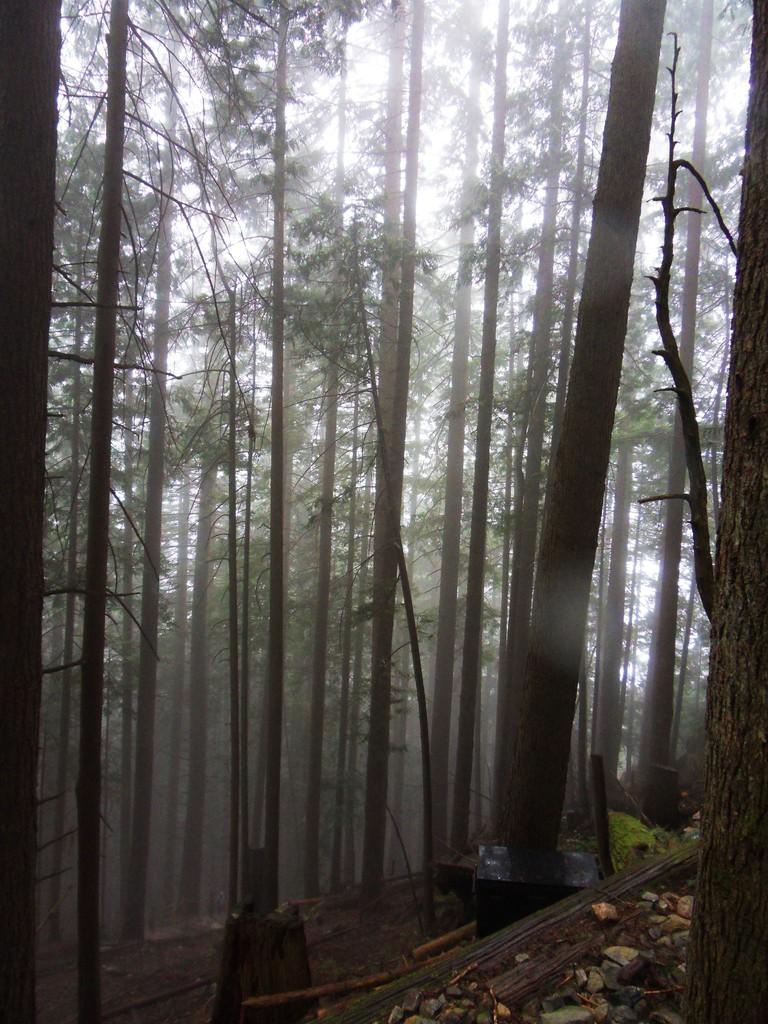Can you describe this image briefly? In this image there are rocks on the bottom. At the background there are trees. 